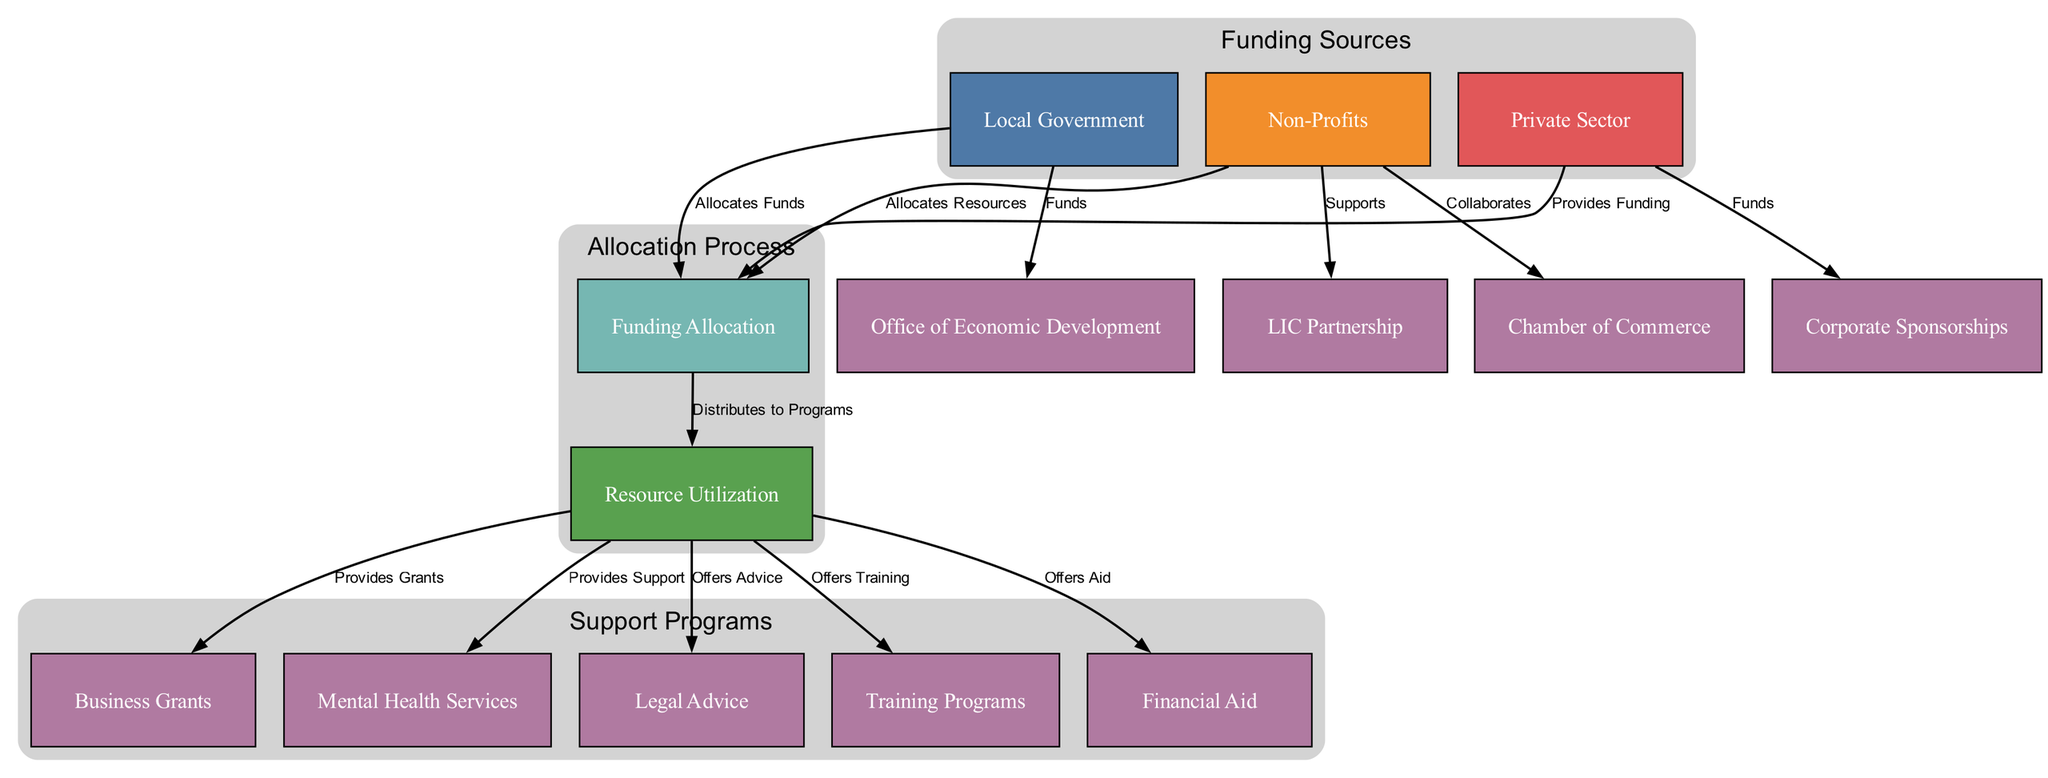What are the three main funding sources? The diagram indicates three main sources of funding: Local Government, Non-Profits, and Private Sector. These are specifically listed as nodes in the diagram, confirming their roles in allocating resources.
Answer: Local Government, Non-Profits, Private Sector How many support programs are listed in the diagram? By counting the nodes that fall under the "Support Programs" cluster, there are five programs listed: Business Grants, Mental Health Services, Legal Advice, Training Programs, and Financial Aid.
Answer: Five What does Local Government allocate? The diagram clearly shows that Local Government allocates funds. This relationship is indicated by the edge labeled "Allocates Funds" from Local Government to Funding Allocation.
Answer: Funds Which organization collaborates with Non-Profits? The Chamber of Commerce collaborates with Non-Profits as indicated by the edge labeled "Collaborates" from Non-Profits to Chamber of Commerce in the diagram.
Answer: Chamber of Commerce What is the purpose of the edge labeled "Provides Grants"? This edge connects Resource Utilization and Business Grants and indicates that the purpose is to show that Resource Utilization provides grants to business owners. This reflects the outcome of resource allocation.
Answer: Provides Grants Which funding sources support the Office of Economic Development? The Local Government is explicitly shown to fund the Office of Economic Development as represented by the edge labeled "Funds" that connects Local Government to Office of Economic Development.
Answer: Local Government How many edges connect to the resource utilization node? The Resource Utilization node has five outgoing edges, which direct to Business Grants, Mental Health Services, Legal Advice, Training Programs, and Financial Aid, indicating the distribution of resources to these programs.
Answer: Five What type of training does Resource Utilization offer? Resource Utilization offers training programs as indicated by the edge labeled "Offers Training" connecting Resource Utilization to Training Programs, reflecting the support provided to small business owners.
Answer: Training Programs Which sector provides corporate sponsorships? The Private Sector is noted to provide corporate sponsorships, as shown by the edge labeled "Funds" that goes to Corporate Sponsorships, indicating that this sector contributes in this way.
Answer: Private Sector 